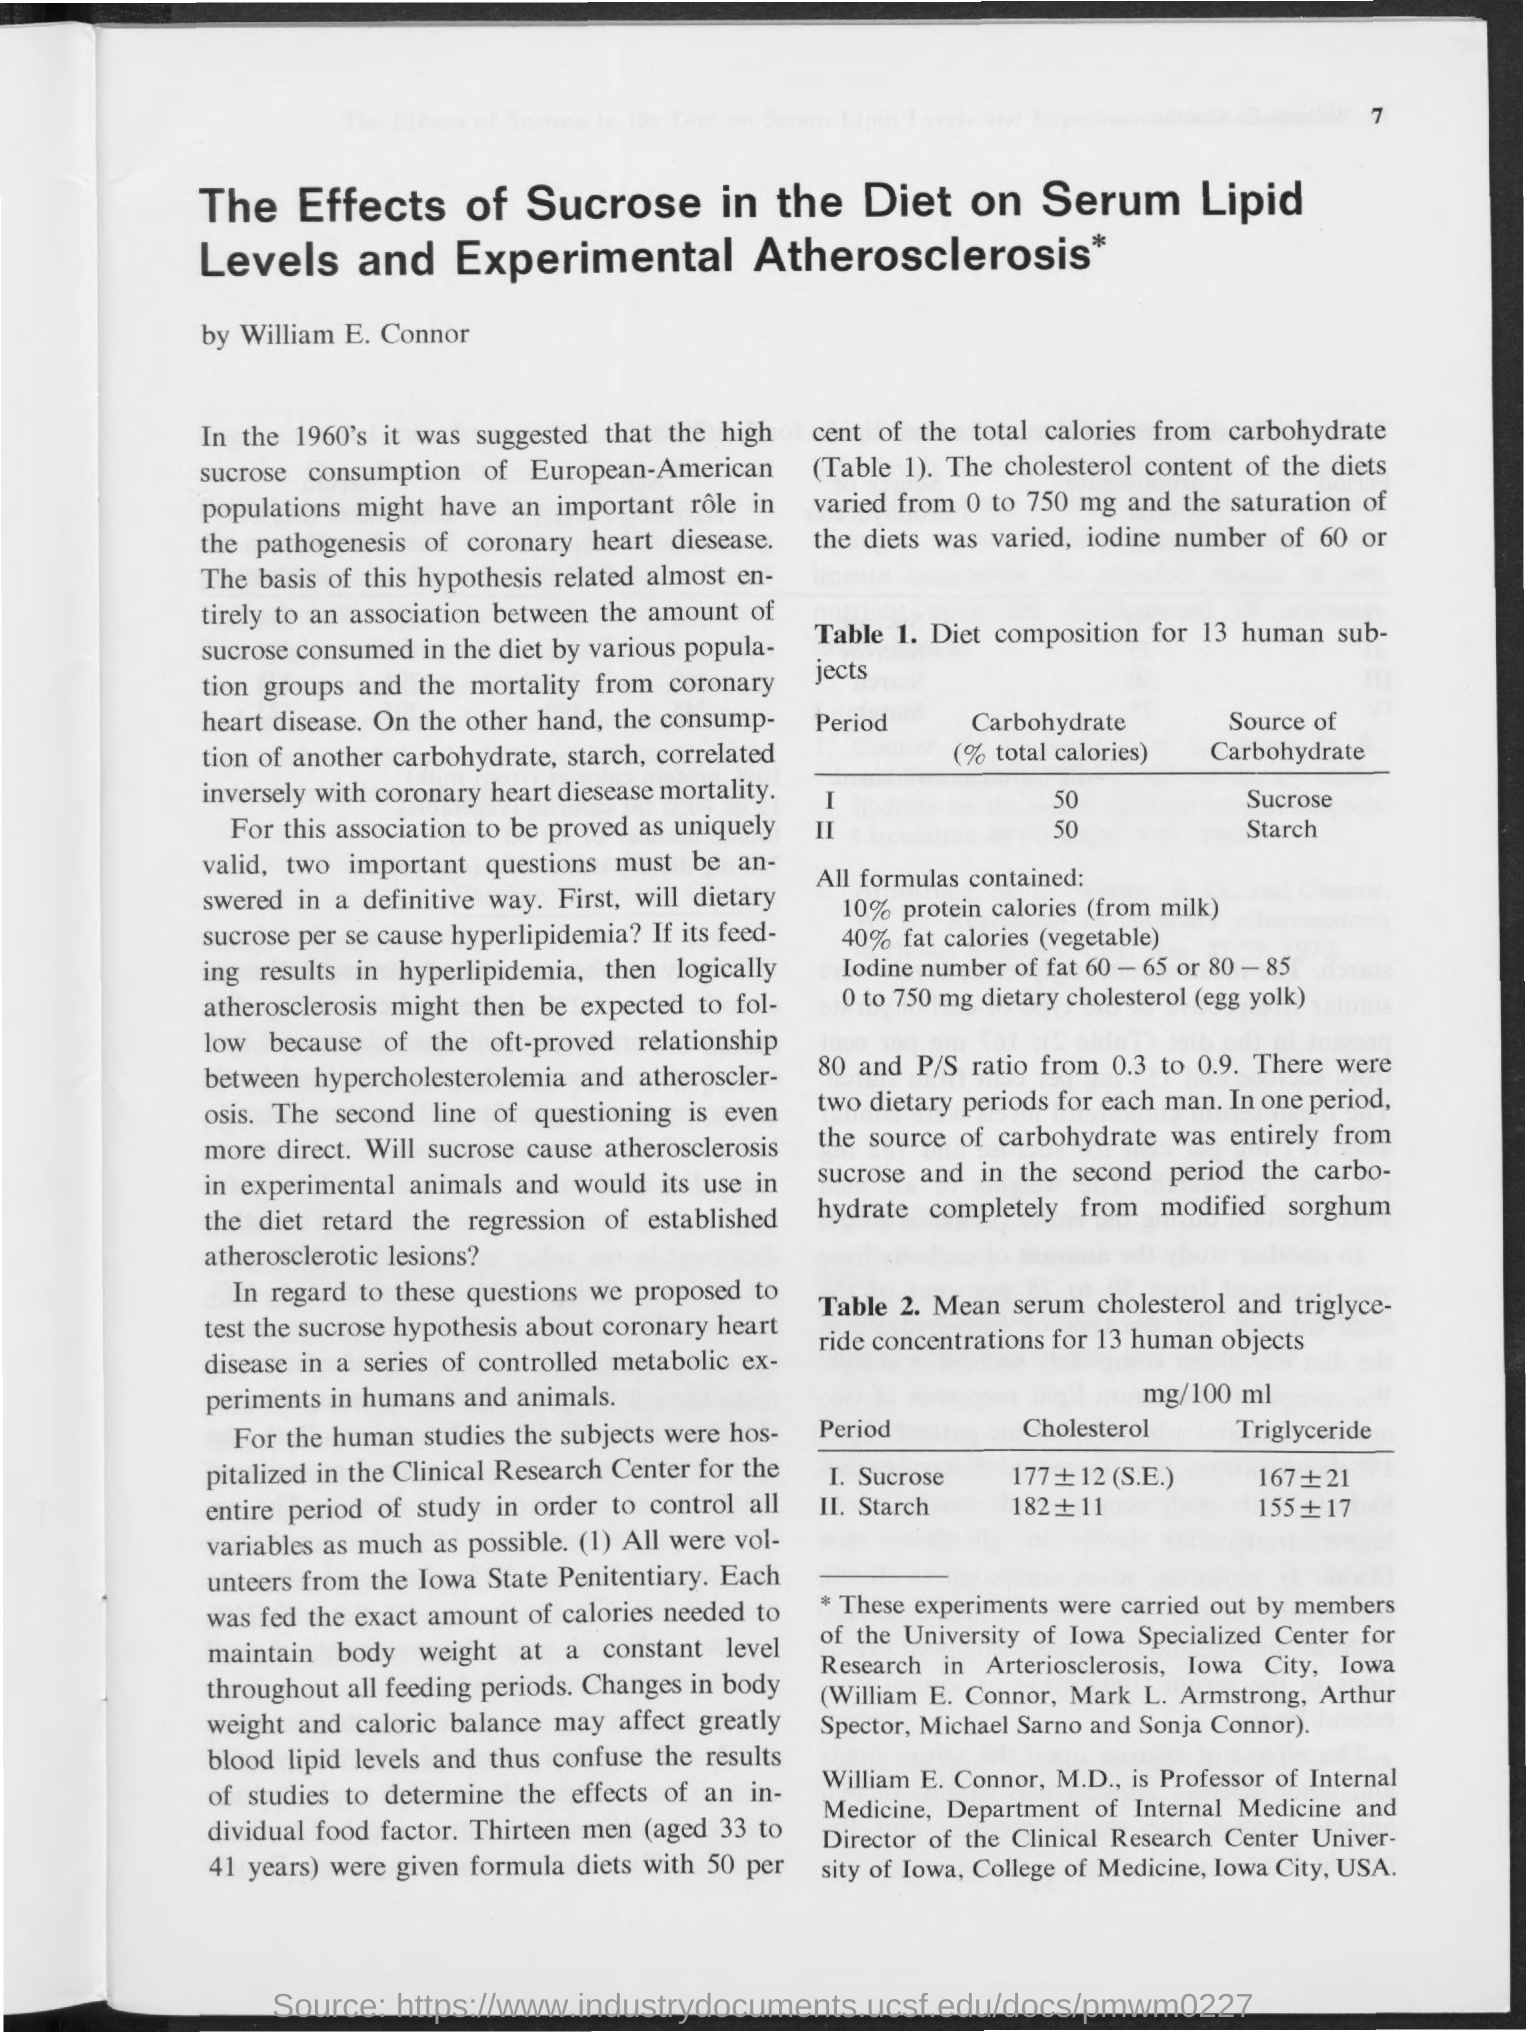What is the value of carbohydrate (% total calories) in period 1 ?
Provide a succinct answer. 50. What is the value of carbohydrate (% total calories)in period 2 ?
Offer a terse response. 50. What is the source of carbohydrate in period 1 ?
Make the answer very short. Sucrose. What is the source of carbohydrate in period 2 ?
Give a very brief answer. Starch. 